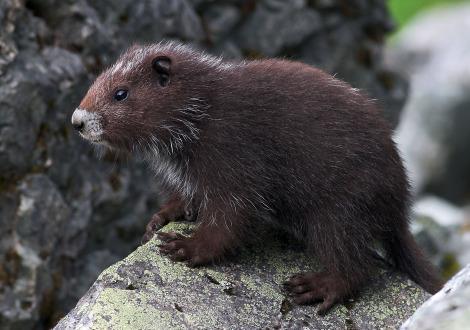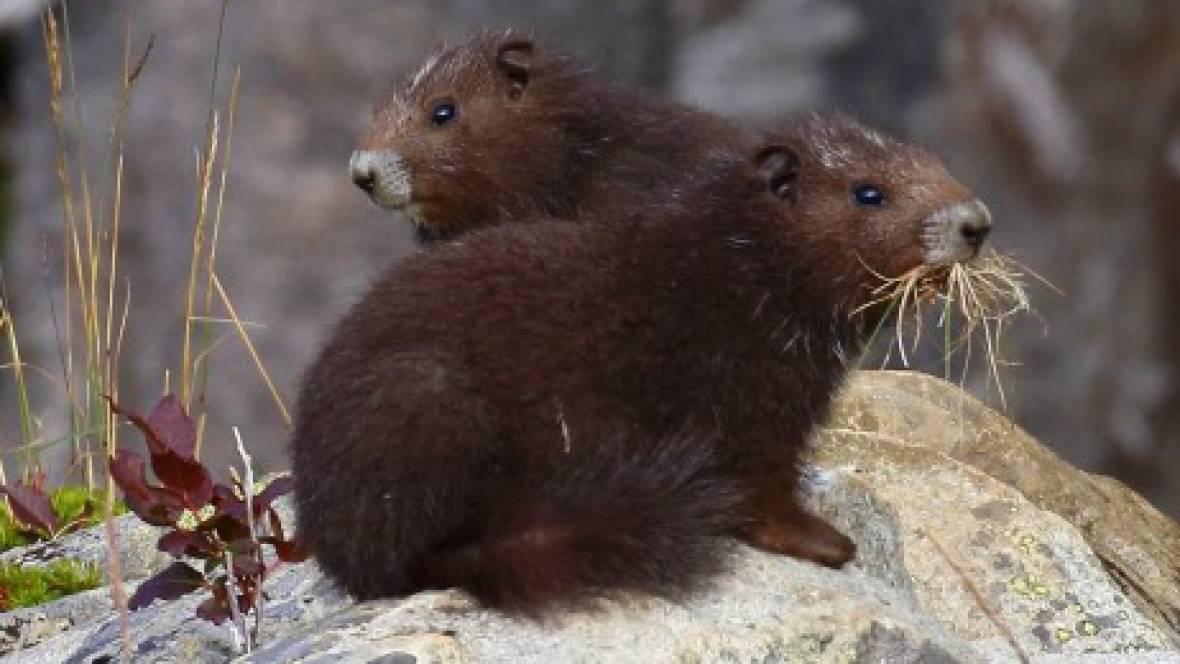The first image is the image on the left, the second image is the image on the right. Examine the images to the left and right. Is the description "One image contains twice as many marmots as the other image." accurate? Answer yes or no. Yes. The first image is the image on the left, the second image is the image on the right. Given the left and right images, does the statement "The left and right image contains a total of three groundhogs." hold true? Answer yes or no. Yes. 